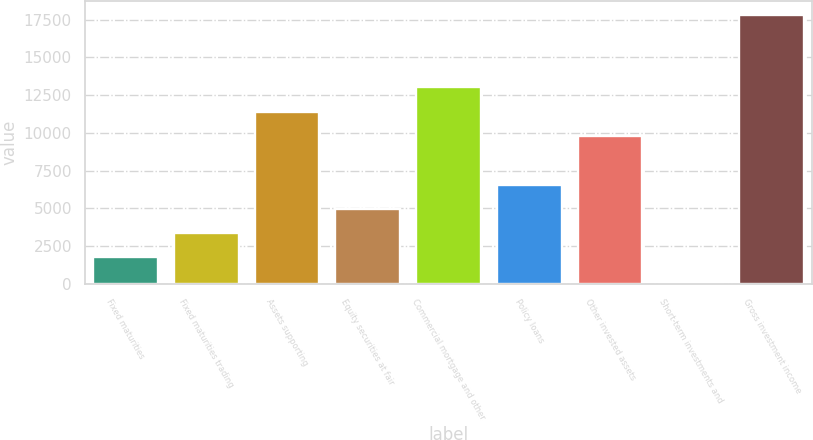<chart> <loc_0><loc_0><loc_500><loc_500><bar_chart><fcel>Fixed maturities<fcel>Fixed maturities trading<fcel>Assets supporting<fcel>Equity securities at fair<fcel>Commercial mortgage and other<fcel>Policy loans<fcel>Other invested assets<fcel>Short-term investments and<fcel>Gross investment income<nl><fcel>1753.1<fcel>3361.2<fcel>11401.7<fcel>4969.3<fcel>13009.8<fcel>6577.4<fcel>9793.6<fcel>145<fcel>17834.1<nl></chart> 